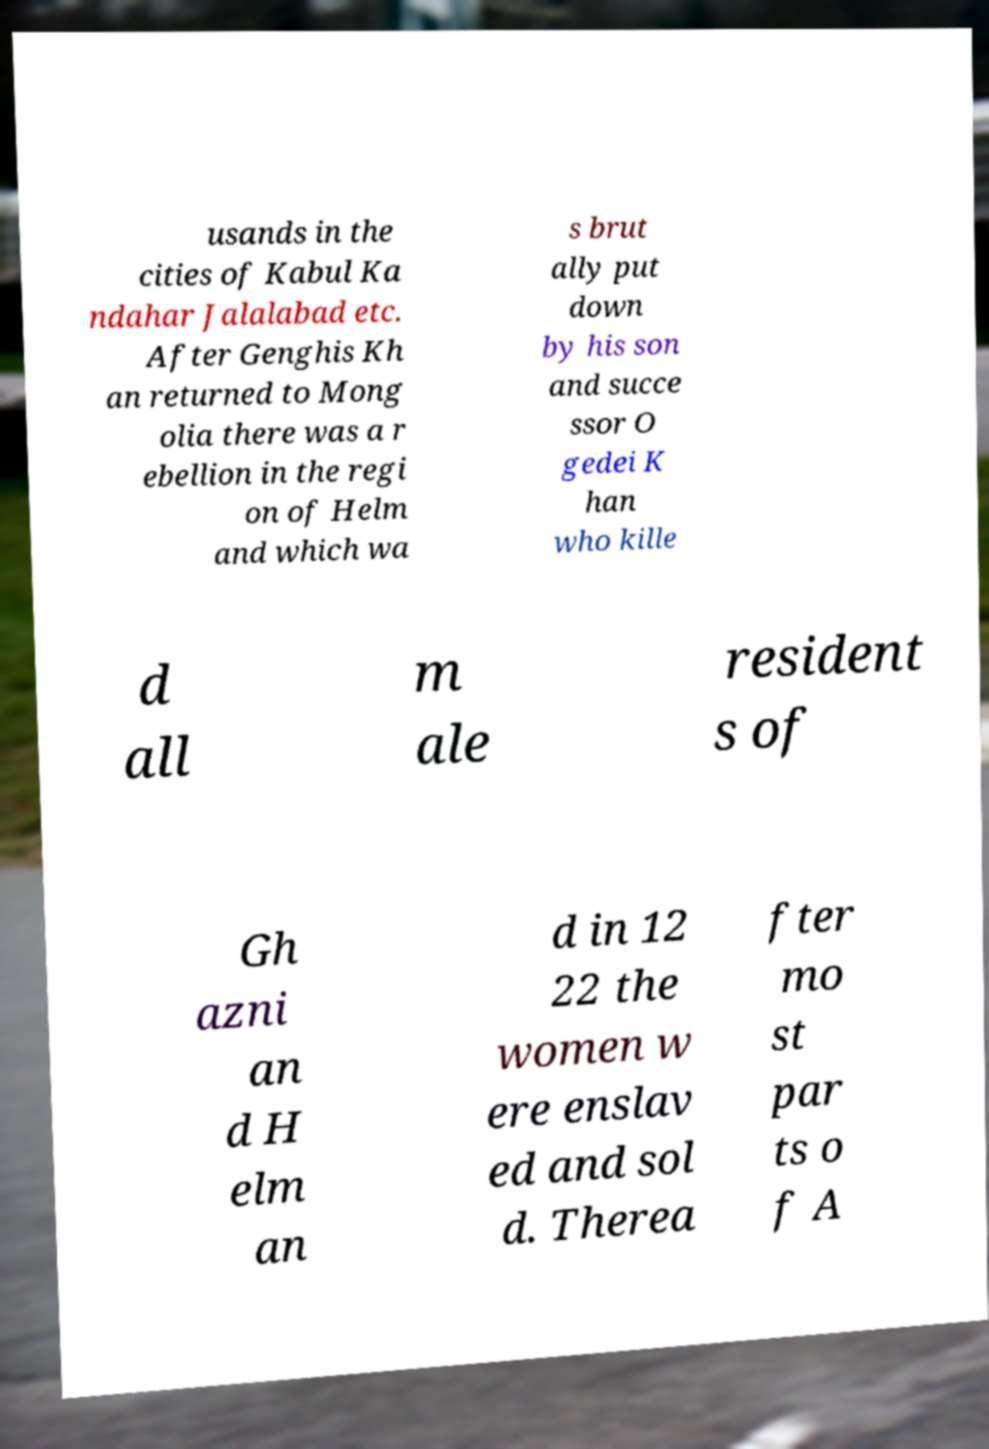Please read and relay the text visible in this image. What does it say? usands in the cities of Kabul Ka ndahar Jalalabad etc. After Genghis Kh an returned to Mong olia there was a r ebellion in the regi on of Helm and which wa s brut ally put down by his son and succe ssor O gedei K han who kille d all m ale resident s of Gh azni an d H elm an d in 12 22 the women w ere enslav ed and sol d. Therea fter mo st par ts o f A 